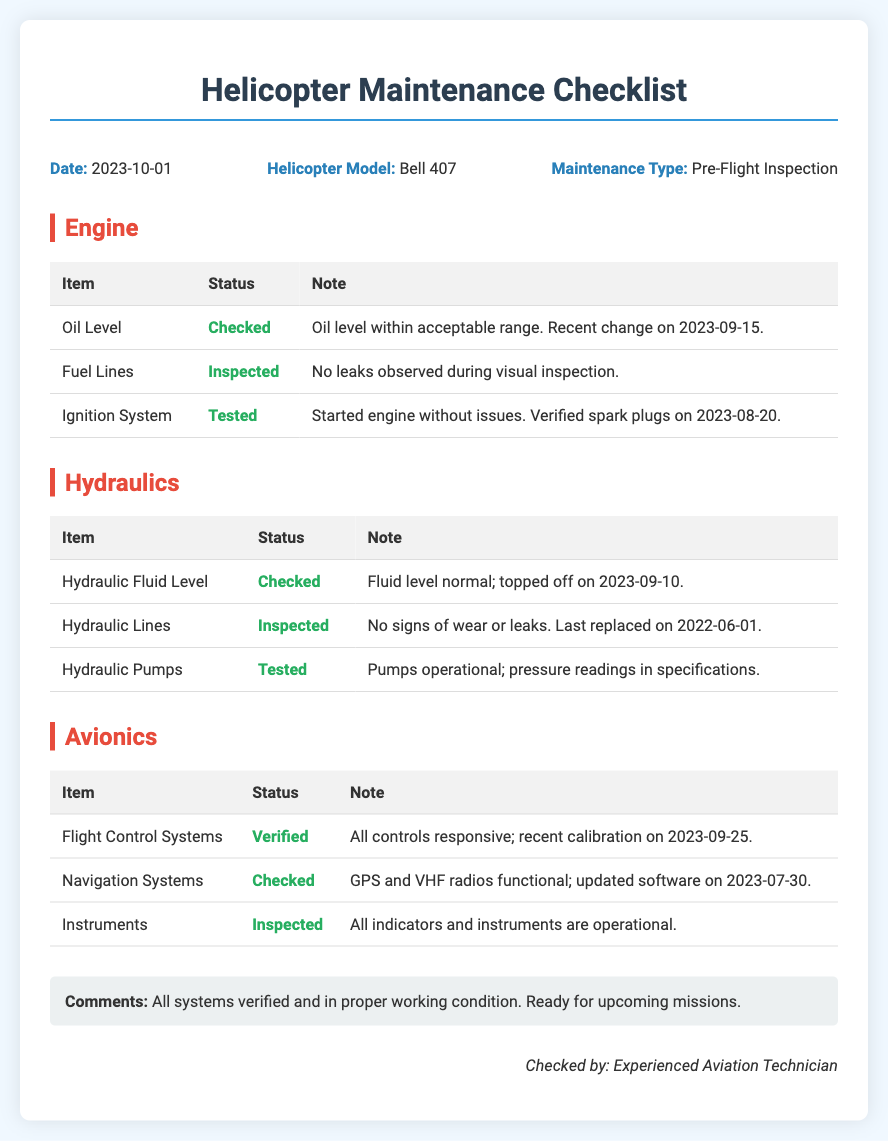What is the date of the maintenance checklist? The date is specifically mentioned in the document's header section.
Answer: 2023-10-01 What is the helicopter model? The model is stated in the same header section as the date.
Answer: Bell 407 When was the oil level last changed? The note about the oil level provides the date of the last change.
Answer: 2023-09-15 What was the date of the recent calibration of the flight control systems? The calibration date is noted in the avionics section under flight control systems.
Answer: 2023-09-25 How is the status of the hydraulic fluid level described? The hydraulic fluid level is listed as 'Checked' and further explained in the note.
Answer: Checked What was noted about the fuel lines during inspection? The status of the fuel lines and observations made during visual inspection are provided.
Answer: No leaks observed during visual inspection Which system was operational with pressure readings in specifications? The relevant note refers to a specific component in the hydraulics section.
Answer: Hydraulic Pumps What kind of maintenance type is listed? The type of maintenance is explicitly mentioned in the opening section.
Answer: Pre-Flight Inspection Are all systems verified and ready for missions? The comments section provides a summary of the overall system condition.
Answer: Yes 